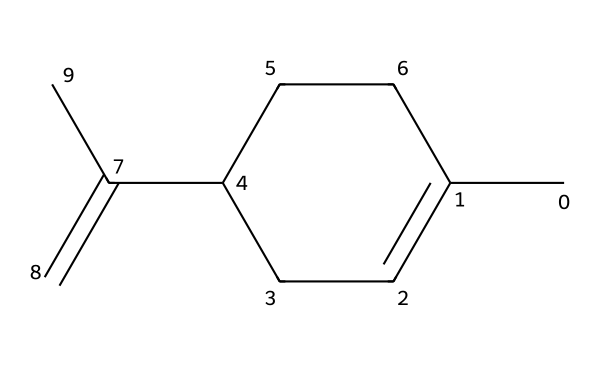How many carbon atoms are in limonene? To find the number of carbon atoms, count each "C" in the SMILES representation. The SMILES indicates there are 10 carbon atoms in total.
Answer: 10 What is the molecular formula of limonene? The number of carbons (C) is 10 and the number of hydrogens (H) can be derived from the structure which indicates a total of 16 due to the saturation level. Thus, the molecular formula is C10H16.
Answer: C10H16 How many double bonds are present in limonene? In the SMILES structure, the presence of the "=" symbol indicates double bonds. There are two double bonds in limonene.
Answer: 2 What functional group is indicated in limonene? The presence of the double bond (C=C) suggests that the compound has alkene characteristics, which is a type of functional group with at least one C=C bond.
Answer: alkene How many geometric isomers can limonene have? Limonene can exist in two geometric isomer forms due to the presence of a double bond that can have different spatial arrangements (cis and trans). Thus, the geometrical configurations allow for these isomeric forms.
Answer: 2 Which geometric isomer of limonene has a citrusy aroma? The cis isomer of limonene is known for its citrus scent, commonly used in flavoring and fragrances, which gives it that characteristic smell.
Answer: cis What type of isomerism is exhibited by limonene? Limonene shows geometric isomerism because the arrangement of groups around the double bonds can differ. This characteristic is specific to alkenes containing restricted rotation around the double bond.
Answer: geometric 